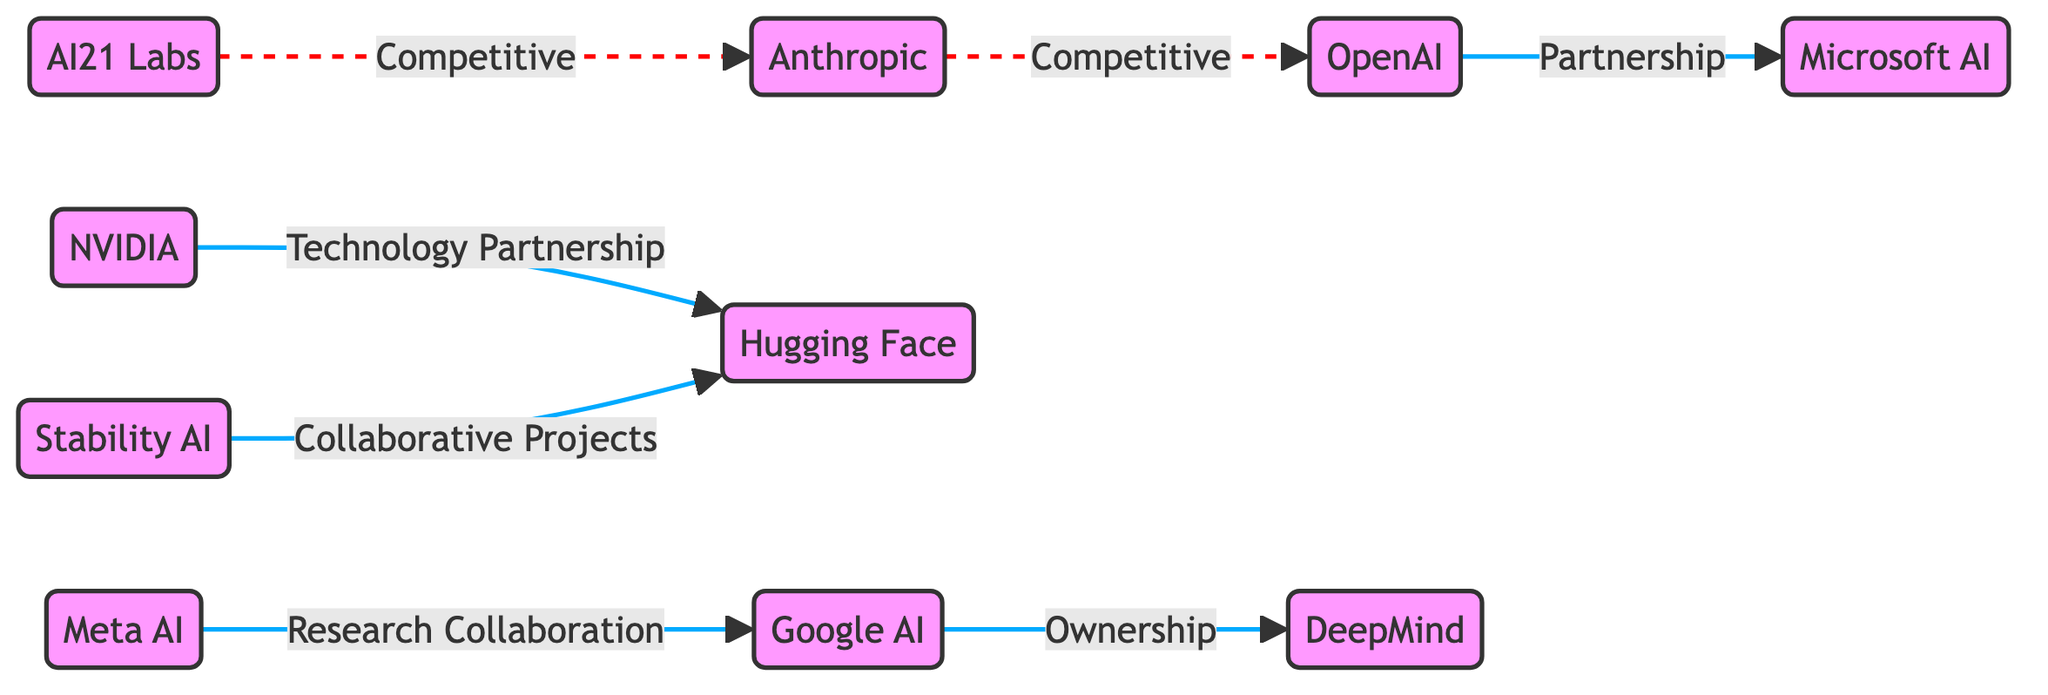What is the total number of nodes in the diagram? The diagram lists ten companies in the nodes section: OpenAI, DeepMind, Anthropic, StabilityAI, HuggingFace, GoogleAI, MicrosoftAI, NVIDIA, MetaAI, and AI21Labs. Counting these gives a total of ten nodes.
Answer: 10 Which company has a partnership relationship with Microsoft AI? In the edges section, the relationship between OpenAI and MicrosoftAI is described as a "Partnership". Thus, OpenAI is the company that has a partnership with Microsoft AI.
Answer: OpenAI What is the relationship type between Google AI and DeepMind? The edge connecting GoogleAI to DeepMind is labeled "Ownership", indicating the relationship type between these two companies is one of ownership.
Answer: Ownership How many companies are identified as competitors to Anthropic? The diagram shows two competitors to Anthropic: OpenAI (labeled as "Competitive") and AI21 Labs (also labeled as "Competitive"). Counting these gives us two competitors.
Answer: 2 What type of collaboration exists between NVIDIA and Hugging Face? The relationship between NVIDIA and HuggingFace is labeled "Technology Partnership", which defines the nature of their collaboration as a technology-focused partnership.
Answer: Technology Partnership Which two companies collaborate on projects according to the diagram? StabilityAI and HuggingFace have a connecting edge labeled "Collaborative Projects". This indicates that these two companies are involved in collaborative projects.
Answer: StabilityAI and HuggingFace How many competitive relationships are depicted in the diagram? There are three competitive relationships indicated by the dashed lines: Anthropic to OpenAI, AI21 Labs to Anthropic, and one more indicated by a relationship but with the same types of connections. Counting these gives a total of three competitive relationships.
Answer: 3 Which company has a research collaboration with Google AI? MetaAI is connected to GoogleAI with a relationship labeled "Research Collaboration". Therefore, MetaAI is the company that collaborates with Google AI on research.
Answer: MetaAI Which company does NVIDIA have a technology partnership with? According to the edges section, NVIDIA is connected to HuggingFace, and the relationship is described as a "Technology Partnership". HuggingFace is therefore the company that NVIDIA collaborates with in this capacity.
Answer: HuggingFace 